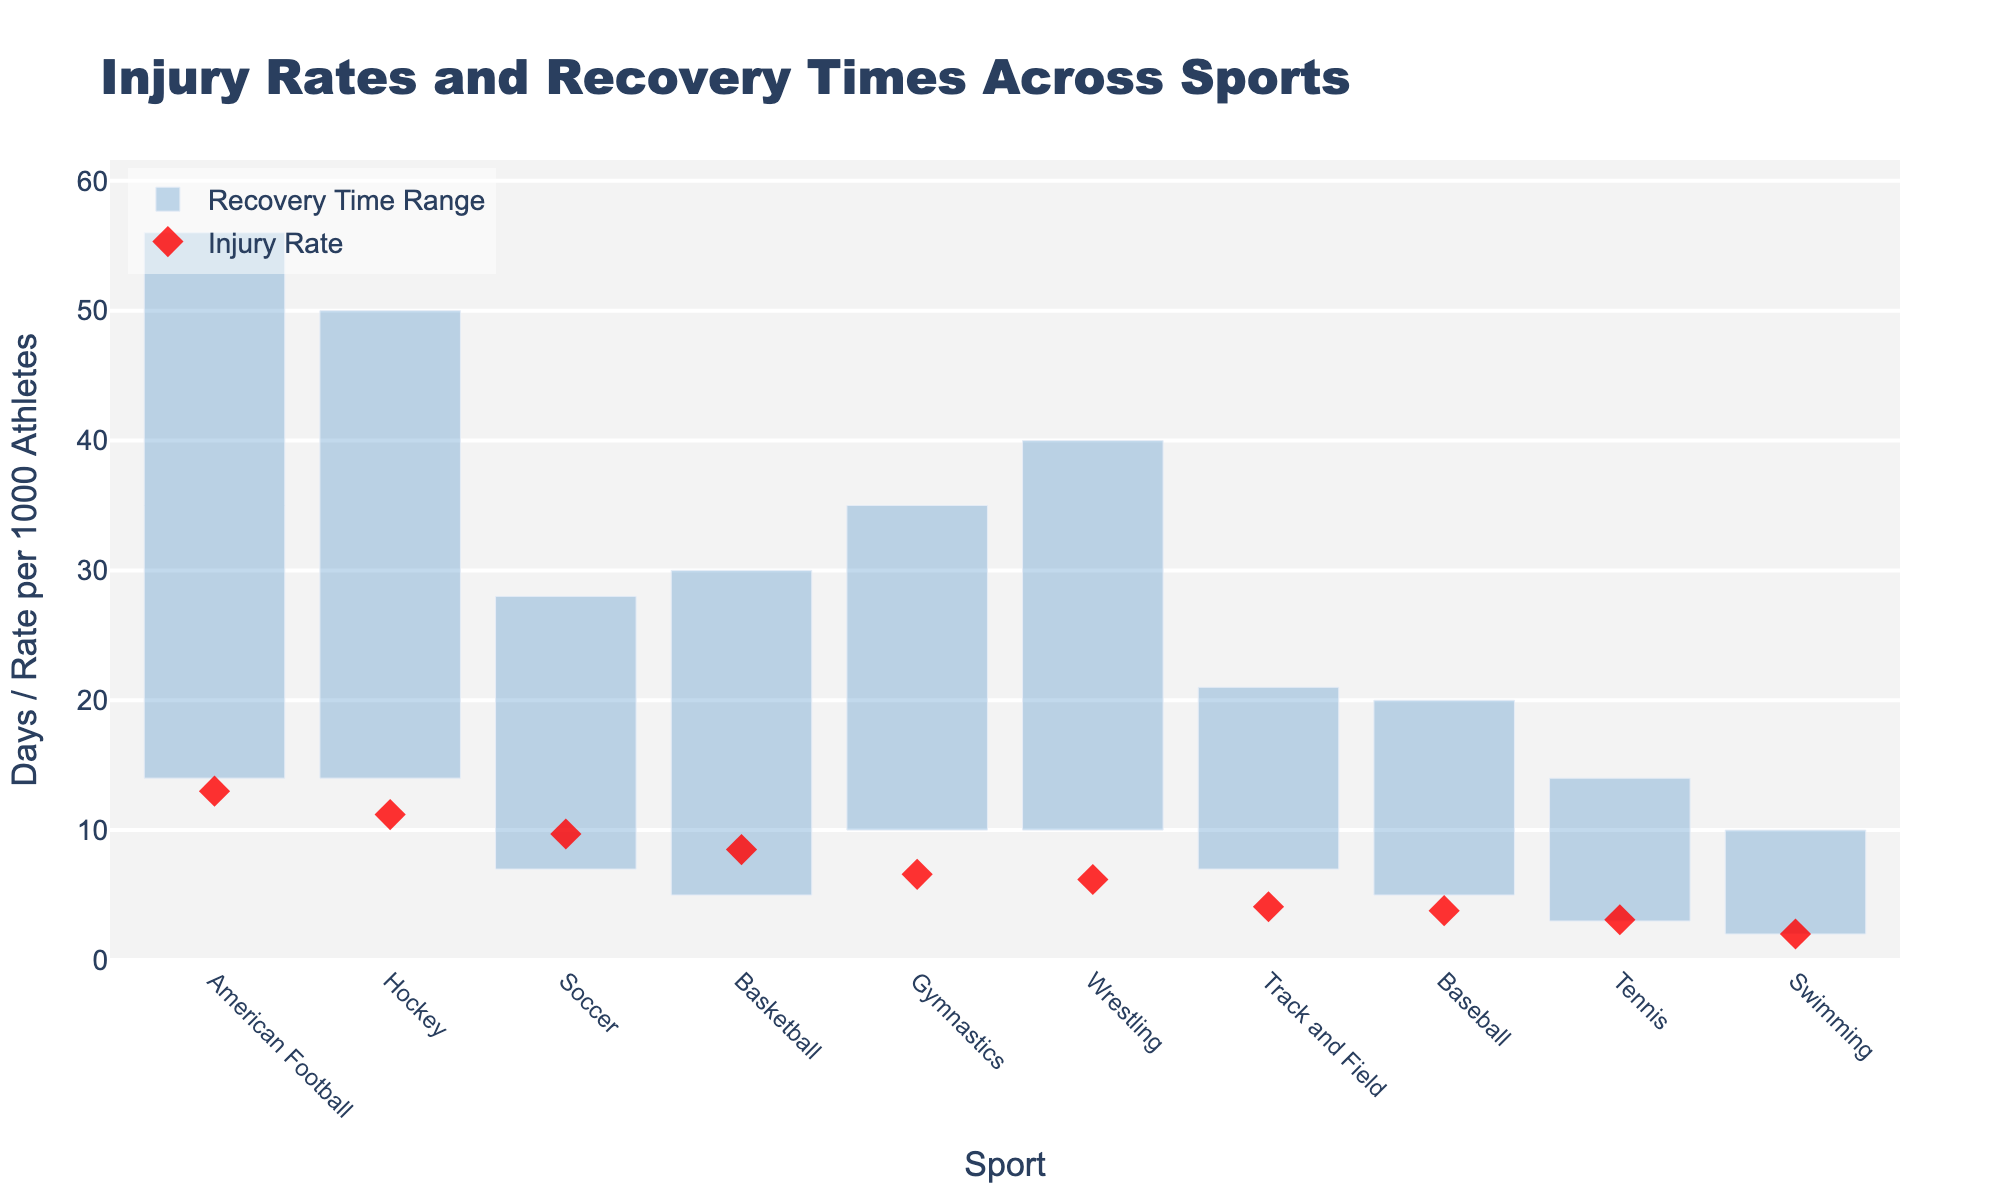What is the title of the plot? The title is usually positioned at the top of the figure. It provides an overview or summary of the figure's content.
Answer: Injury Rates and Recovery Times Across Sports Which sport has the highest injury rate per 1000 athletes? Identify the sport with the highest dot marker on the vertical axis representing injury rates.
Answer: American Football What is the recovery time range for Hockey? Look at the length of the bar corresponding to Hockey, which represents the difference between max and min recovery times.
Answer: 14 to 50 days How many days is the recovery time range for Basketball? Calculate the difference between maximum and minimum recovery times for Basketball by looking at the bar's start and end points.
Answer: 25 days Which sport has the shortest maximum recovery time? Identify the sport with the lowest end point of the bar representing maximum recovery time.
Answer: Swimming Compare the injury rates of Soccer and Baseball. Which is higher, and by how much? Compare the vertical positions of Soccer's and Baseball's dot markers. Subtract Baseball's rate from Soccer's rate.
Answer: Soccer is higher by 5.9 per 1000 athletes Between Gymnastics and Wrestling, which has a wider recovery time range? Measure the lengths of the bars for Gymnastics and Wrestling and compare them.
Answer: Wrestling What is the average recovery time range for Tennis? Identify the min and max recovery times for Tennis, then calculate the average by adding them and dividing by 2. (3 + 14) / 2
Answer: 8.5 days Is the injury rate of Hockey greater than the injury rate of Gymnastics? Compare the vertical positions of the dot markers for Hockey and Gymnastics.
Answer: Yes Which sport has the smallest difference between injury rate and maximum recovery time? For each sport, subtract the injury rate from the maximum recovery time, then identify the smallest difference.
Answer: Swimming 